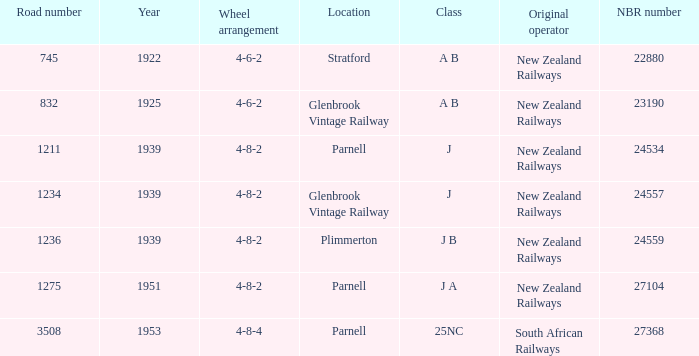Which original operator is in the 25nc class? South African Railways. 